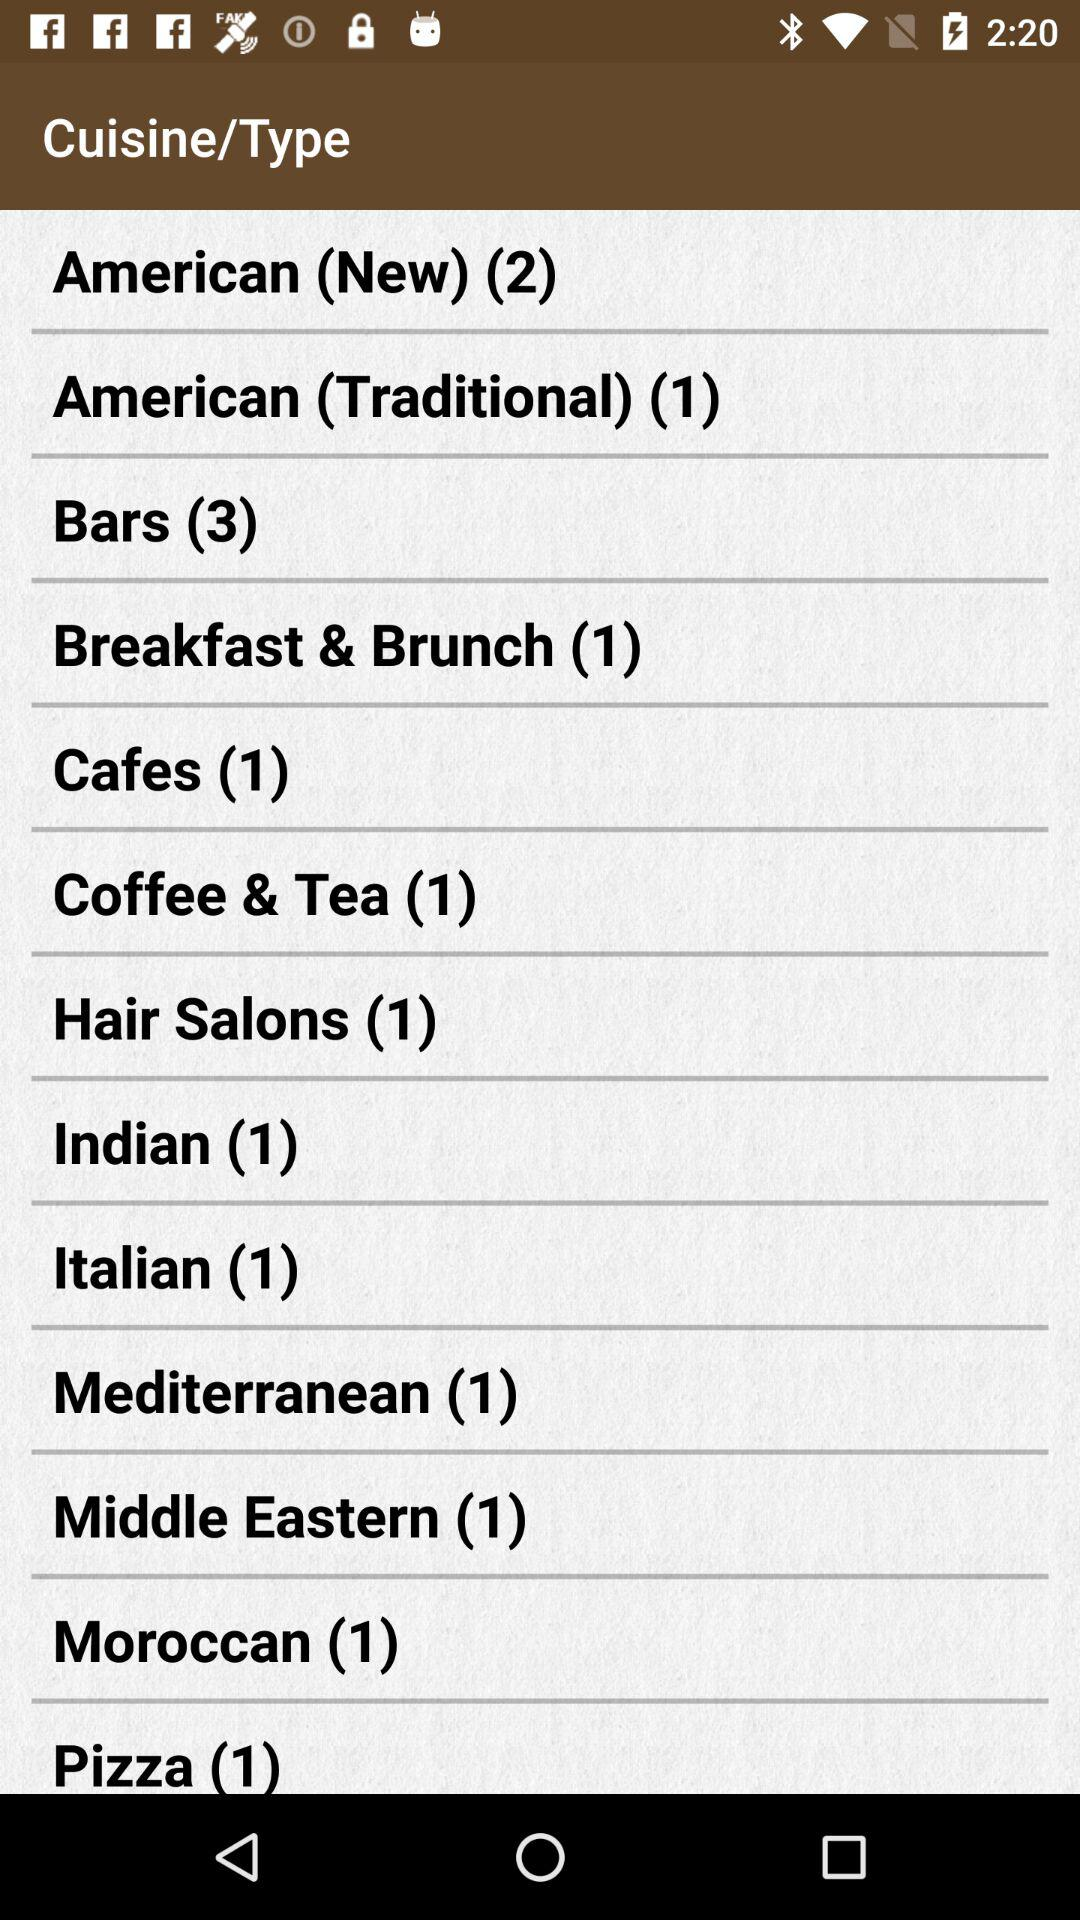How many more bars are there than cafes?
Answer the question using a single word or phrase. 2 